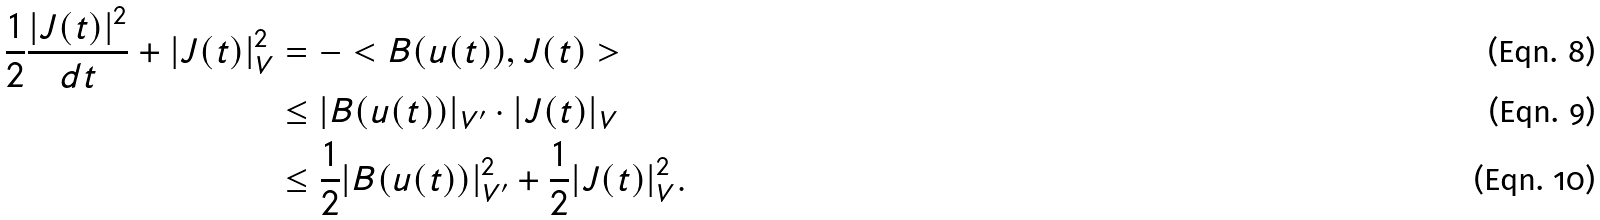Convert formula to latex. <formula><loc_0><loc_0><loc_500><loc_500>\frac { 1 } { 2 } \frac { | J ( t ) | ^ { 2 } } { d t } + | J ( t ) | ^ { 2 } _ { V } & = - < B ( u ( t ) ) , J ( t ) > \\ & \leq | B ( u ( t ) ) | _ { V ^ { \prime } } \cdot | J ( t ) | _ { V } \\ & \leq \frac { 1 } { 2 } | B ( u ( t ) ) | _ { V ^ { \prime } } ^ { 2 } + \frac { 1 } { 2 } | J ( t ) | _ { V } ^ { 2 } .</formula> 